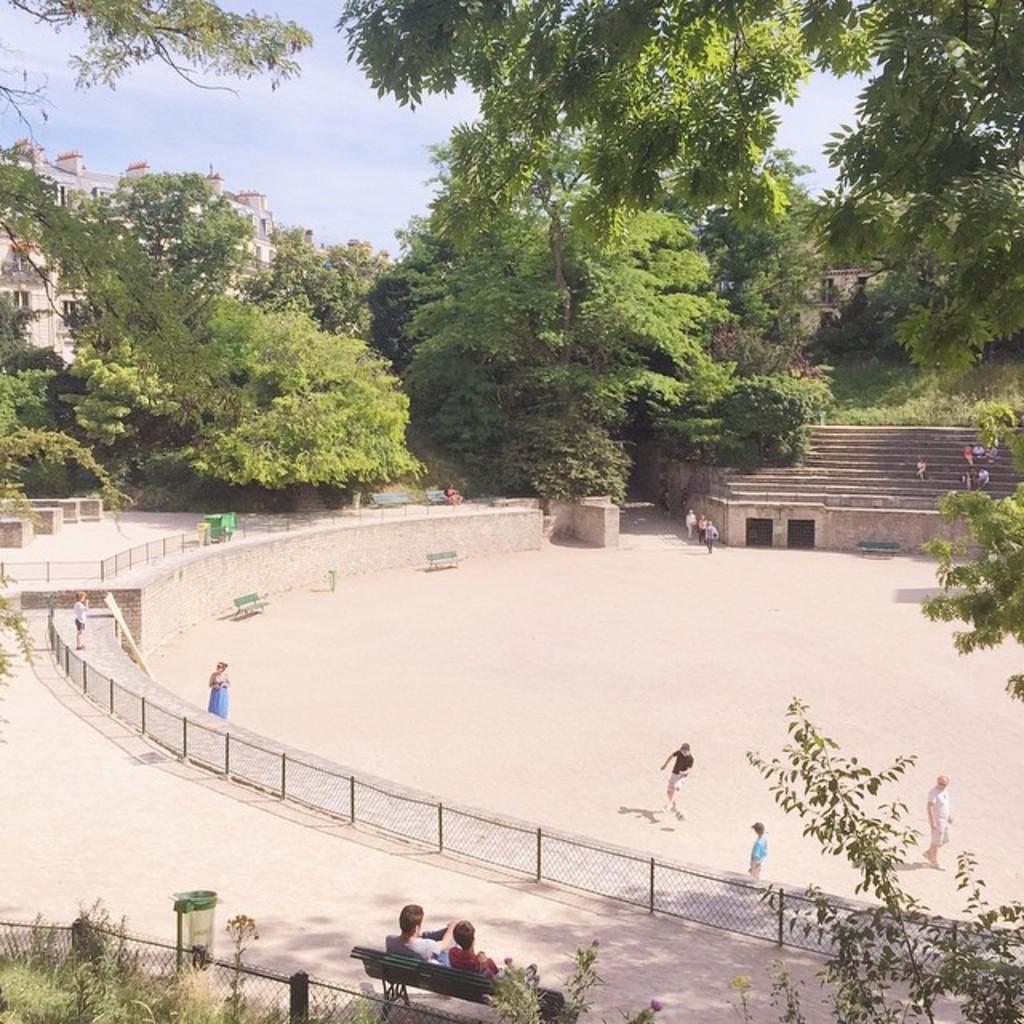Can you describe this image briefly? In this image I can see few persons some are walking and some are sitting. I can also see trees in green color, a building in cream color and the sky is in white and blue color. 